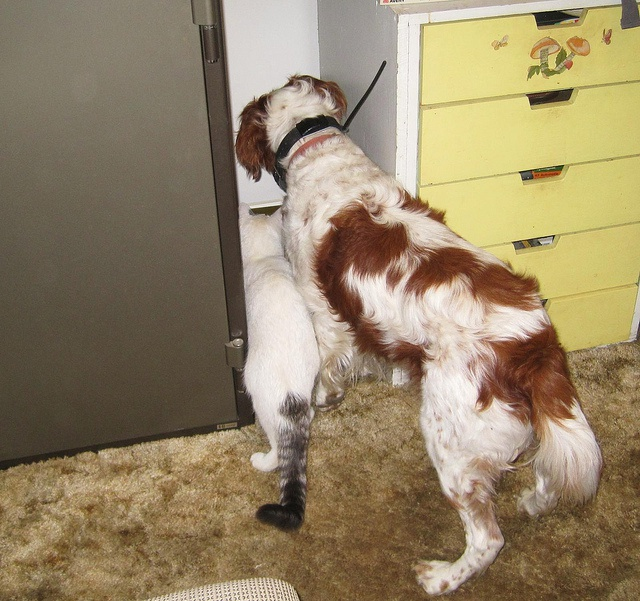Describe the objects in this image and their specific colors. I can see dog in gray, lightgray, maroon, tan, and darkgray tones and cat in gray, lightgray, darkgray, and black tones in this image. 